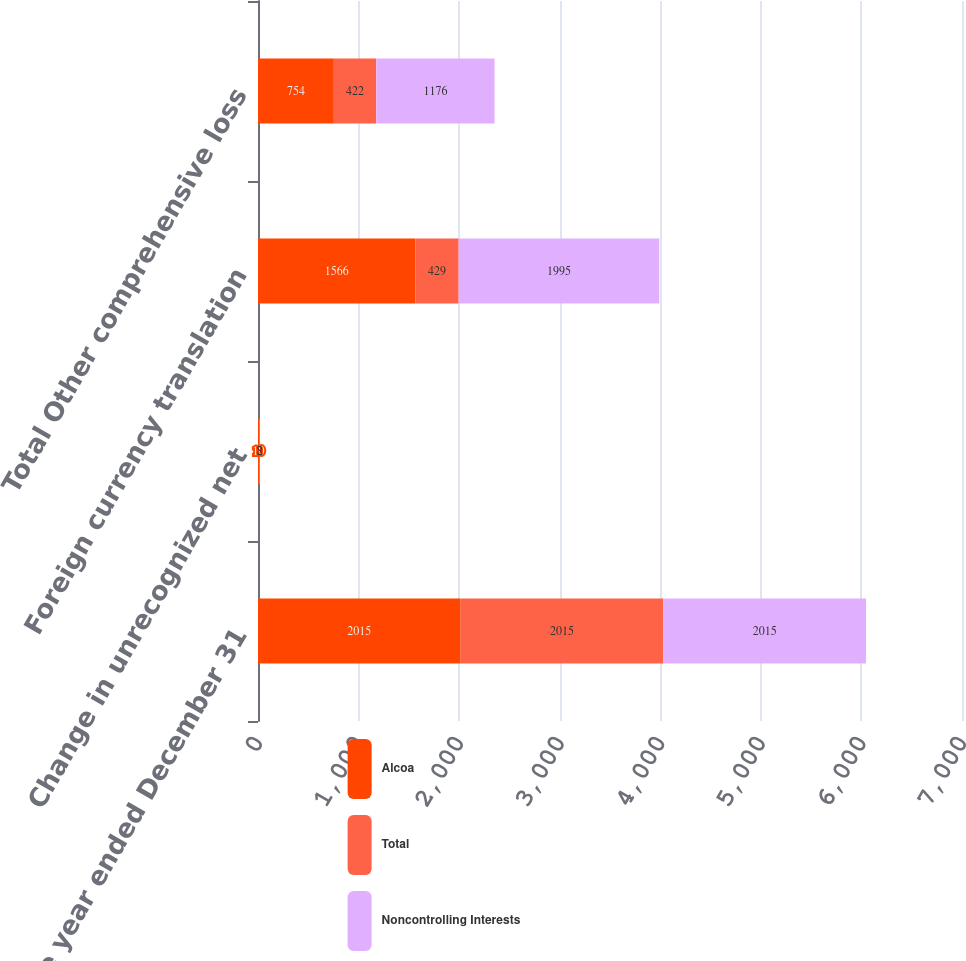Convert chart. <chart><loc_0><loc_0><loc_500><loc_500><stacked_bar_chart><ecel><fcel>For the year ended December 31<fcel>Change in unrecognized net<fcel>Foreign currency translation<fcel>Total Other comprehensive loss<nl><fcel>Alcoa<fcel>2015<fcel>10<fcel>1566<fcel>754<nl><fcel>Total<fcel>2015<fcel>8<fcel>429<fcel>422<nl><fcel>Noncontrolling Interests<fcel>2015<fcel>2<fcel>1995<fcel>1176<nl></chart> 